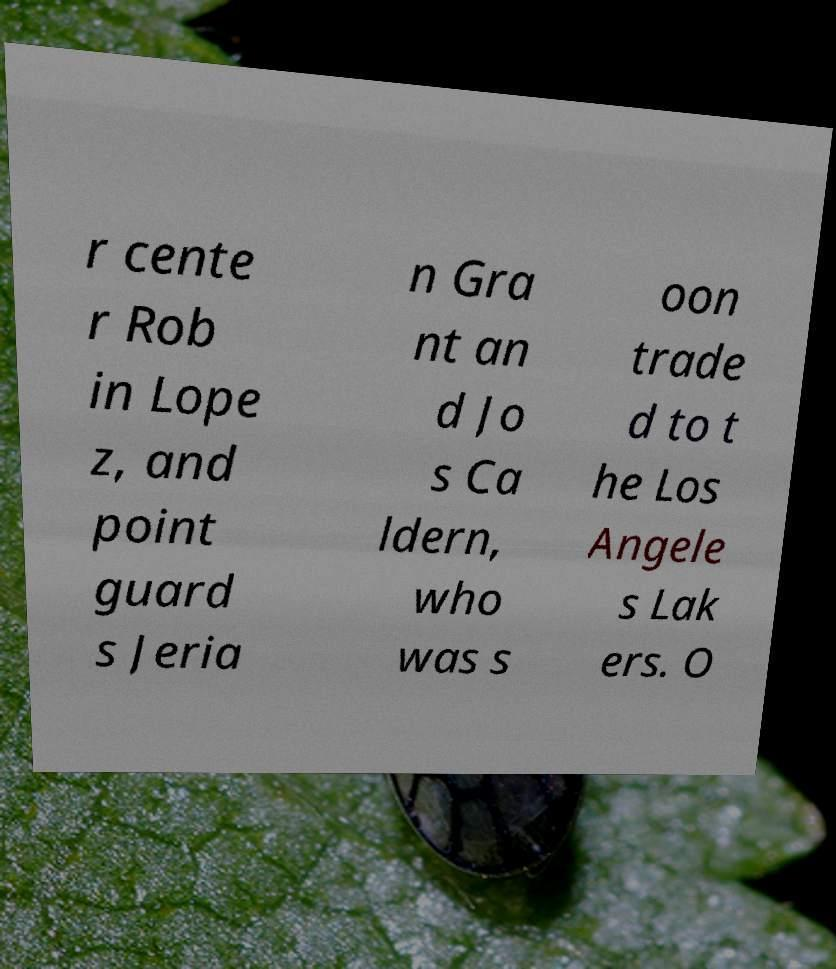Please read and relay the text visible in this image. What does it say? r cente r Rob in Lope z, and point guard s Jeria n Gra nt an d Jo s Ca ldern, who was s oon trade d to t he Los Angele s Lak ers. O 